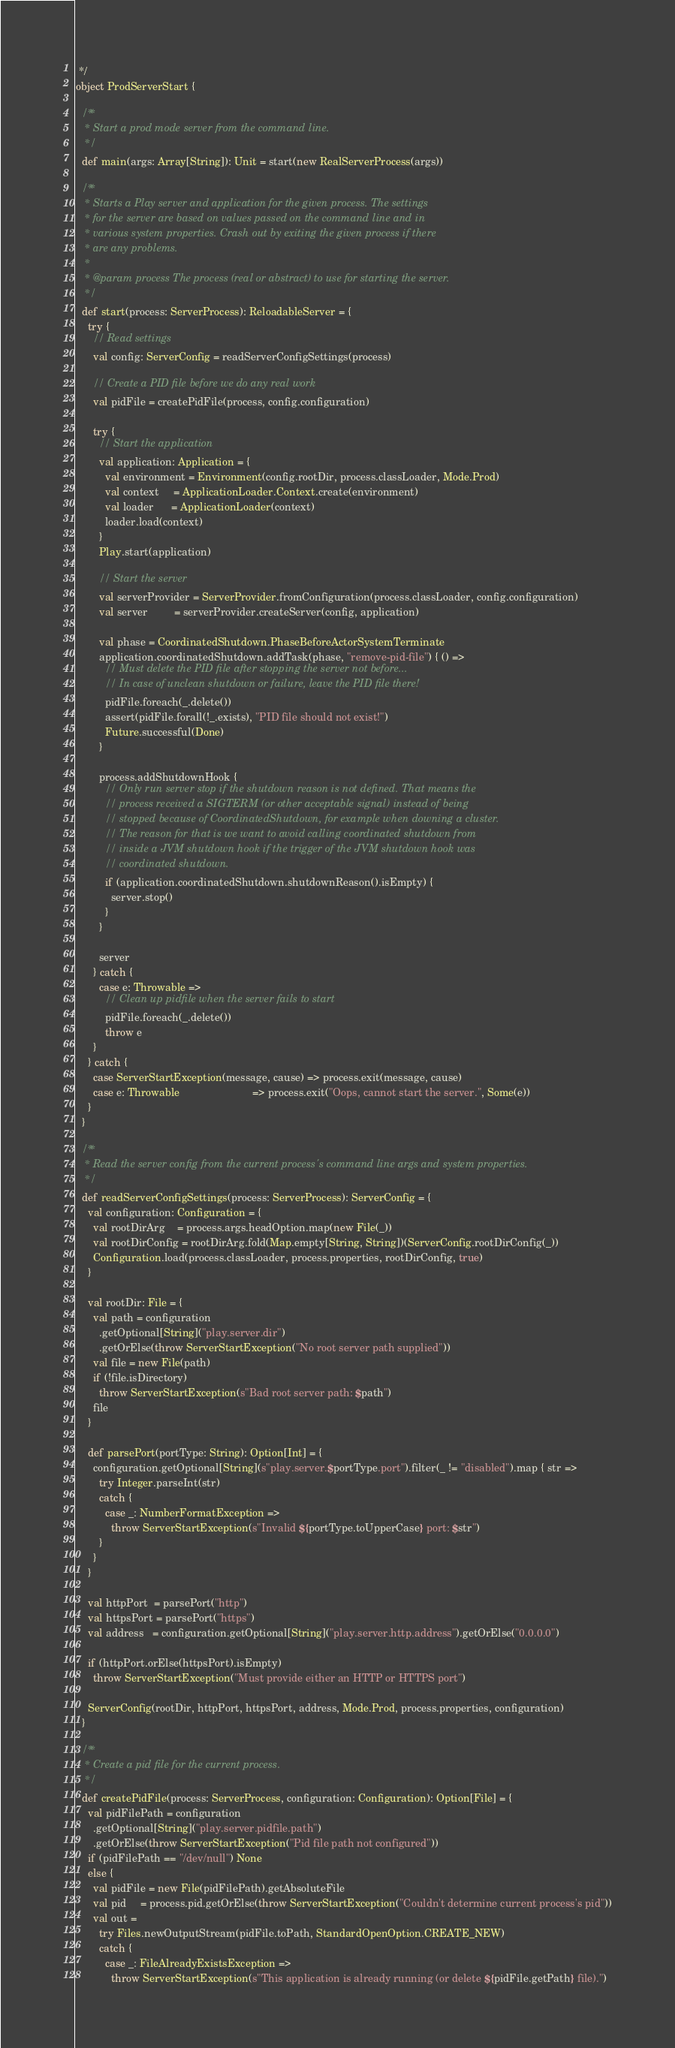<code> <loc_0><loc_0><loc_500><loc_500><_Scala_> */
object ProdServerStart {

  /**
   * Start a prod mode server from the command line.
   */
  def main(args: Array[String]): Unit = start(new RealServerProcess(args))

  /**
   * Starts a Play server and application for the given process. The settings
   * for the server are based on values passed on the command line and in
   * various system properties. Crash out by exiting the given process if there
   * are any problems.
   *
   * @param process The process (real or abstract) to use for starting the server.
   */
  def start(process: ServerProcess): ReloadableServer = {
    try {
      // Read settings
      val config: ServerConfig = readServerConfigSettings(process)

      // Create a PID file before we do any real work
      val pidFile = createPidFile(process, config.configuration)

      try {
        // Start the application
        val application: Application = {
          val environment = Environment(config.rootDir, process.classLoader, Mode.Prod)
          val context     = ApplicationLoader.Context.create(environment)
          val loader      = ApplicationLoader(context)
          loader.load(context)
        }
        Play.start(application)

        // Start the server
        val serverProvider = ServerProvider.fromConfiguration(process.classLoader, config.configuration)
        val server         = serverProvider.createServer(config, application)

        val phase = CoordinatedShutdown.PhaseBeforeActorSystemTerminate
        application.coordinatedShutdown.addTask(phase, "remove-pid-file") { () =>
          // Must delete the PID file after stopping the server not before...
          // In case of unclean shutdown or failure, leave the PID file there!
          pidFile.foreach(_.delete())
          assert(pidFile.forall(!_.exists), "PID file should not exist!")
          Future.successful(Done)
        }

        process.addShutdownHook {
          // Only run server stop if the shutdown reason is not defined. That means the
          // process received a SIGTERM (or other acceptable signal) instead of being
          // stopped because of CoordinatedShutdown, for example when downing a cluster.
          // The reason for that is we want to avoid calling coordinated shutdown from
          // inside a JVM shutdown hook if the trigger of the JVM shutdown hook was
          // coordinated shutdown.
          if (application.coordinatedShutdown.shutdownReason().isEmpty) {
            server.stop()
          }
        }

        server
      } catch {
        case e: Throwable =>
          // Clean up pidfile when the server fails to start
          pidFile.foreach(_.delete())
          throw e
      }
    } catch {
      case ServerStartException(message, cause) => process.exit(message, cause)
      case e: Throwable                         => process.exit("Oops, cannot start the server.", Some(e))
    }
  }

  /**
   * Read the server config from the current process's command line args and system properties.
   */
  def readServerConfigSettings(process: ServerProcess): ServerConfig = {
    val configuration: Configuration = {
      val rootDirArg    = process.args.headOption.map(new File(_))
      val rootDirConfig = rootDirArg.fold(Map.empty[String, String])(ServerConfig.rootDirConfig(_))
      Configuration.load(process.classLoader, process.properties, rootDirConfig, true)
    }

    val rootDir: File = {
      val path = configuration
        .getOptional[String]("play.server.dir")
        .getOrElse(throw ServerStartException("No root server path supplied"))
      val file = new File(path)
      if (!file.isDirectory)
        throw ServerStartException(s"Bad root server path: $path")
      file
    }

    def parsePort(portType: String): Option[Int] = {
      configuration.getOptional[String](s"play.server.$portType.port").filter(_ != "disabled").map { str =>
        try Integer.parseInt(str)
        catch {
          case _: NumberFormatException =>
            throw ServerStartException(s"Invalid ${portType.toUpperCase} port: $str")
        }
      }
    }

    val httpPort  = parsePort("http")
    val httpsPort = parsePort("https")
    val address   = configuration.getOptional[String]("play.server.http.address").getOrElse("0.0.0.0")

    if (httpPort.orElse(httpsPort).isEmpty)
      throw ServerStartException("Must provide either an HTTP or HTTPS port")

    ServerConfig(rootDir, httpPort, httpsPort, address, Mode.Prod, process.properties, configuration)
  }

  /**
   * Create a pid file for the current process.
   */
  def createPidFile(process: ServerProcess, configuration: Configuration): Option[File] = {
    val pidFilePath = configuration
      .getOptional[String]("play.server.pidfile.path")
      .getOrElse(throw ServerStartException("Pid file path not configured"))
    if (pidFilePath == "/dev/null") None
    else {
      val pidFile = new File(pidFilePath).getAbsoluteFile
      val pid     = process.pid.getOrElse(throw ServerStartException("Couldn't determine current process's pid"))
      val out =
        try Files.newOutputStream(pidFile.toPath, StandardOpenOption.CREATE_NEW)
        catch {
          case _: FileAlreadyExistsException =>
            throw ServerStartException(s"This application is already running (or delete ${pidFile.getPath} file).")</code> 